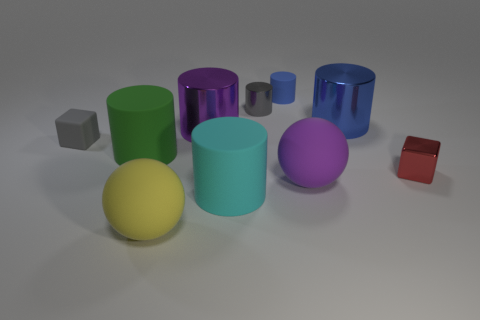Subtract all big blue metal cylinders. How many cylinders are left? 5 Subtract all brown blocks. How many blue cylinders are left? 2 Subtract all purple spheres. How many spheres are left? 1 Subtract 1 cylinders. How many cylinders are left? 5 Subtract all cylinders. How many objects are left? 4 Add 9 big cyan cylinders. How many big cyan cylinders exist? 10 Subtract 0 red balls. How many objects are left? 10 Subtract all brown cylinders. Subtract all blue balls. How many cylinders are left? 6 Subtract all tiny gray metallic cylinders. Subtract all red cubes. How many objects are left? 8 Add 2 big yellow matte objects. How many big yellow matte objects are left? 3 